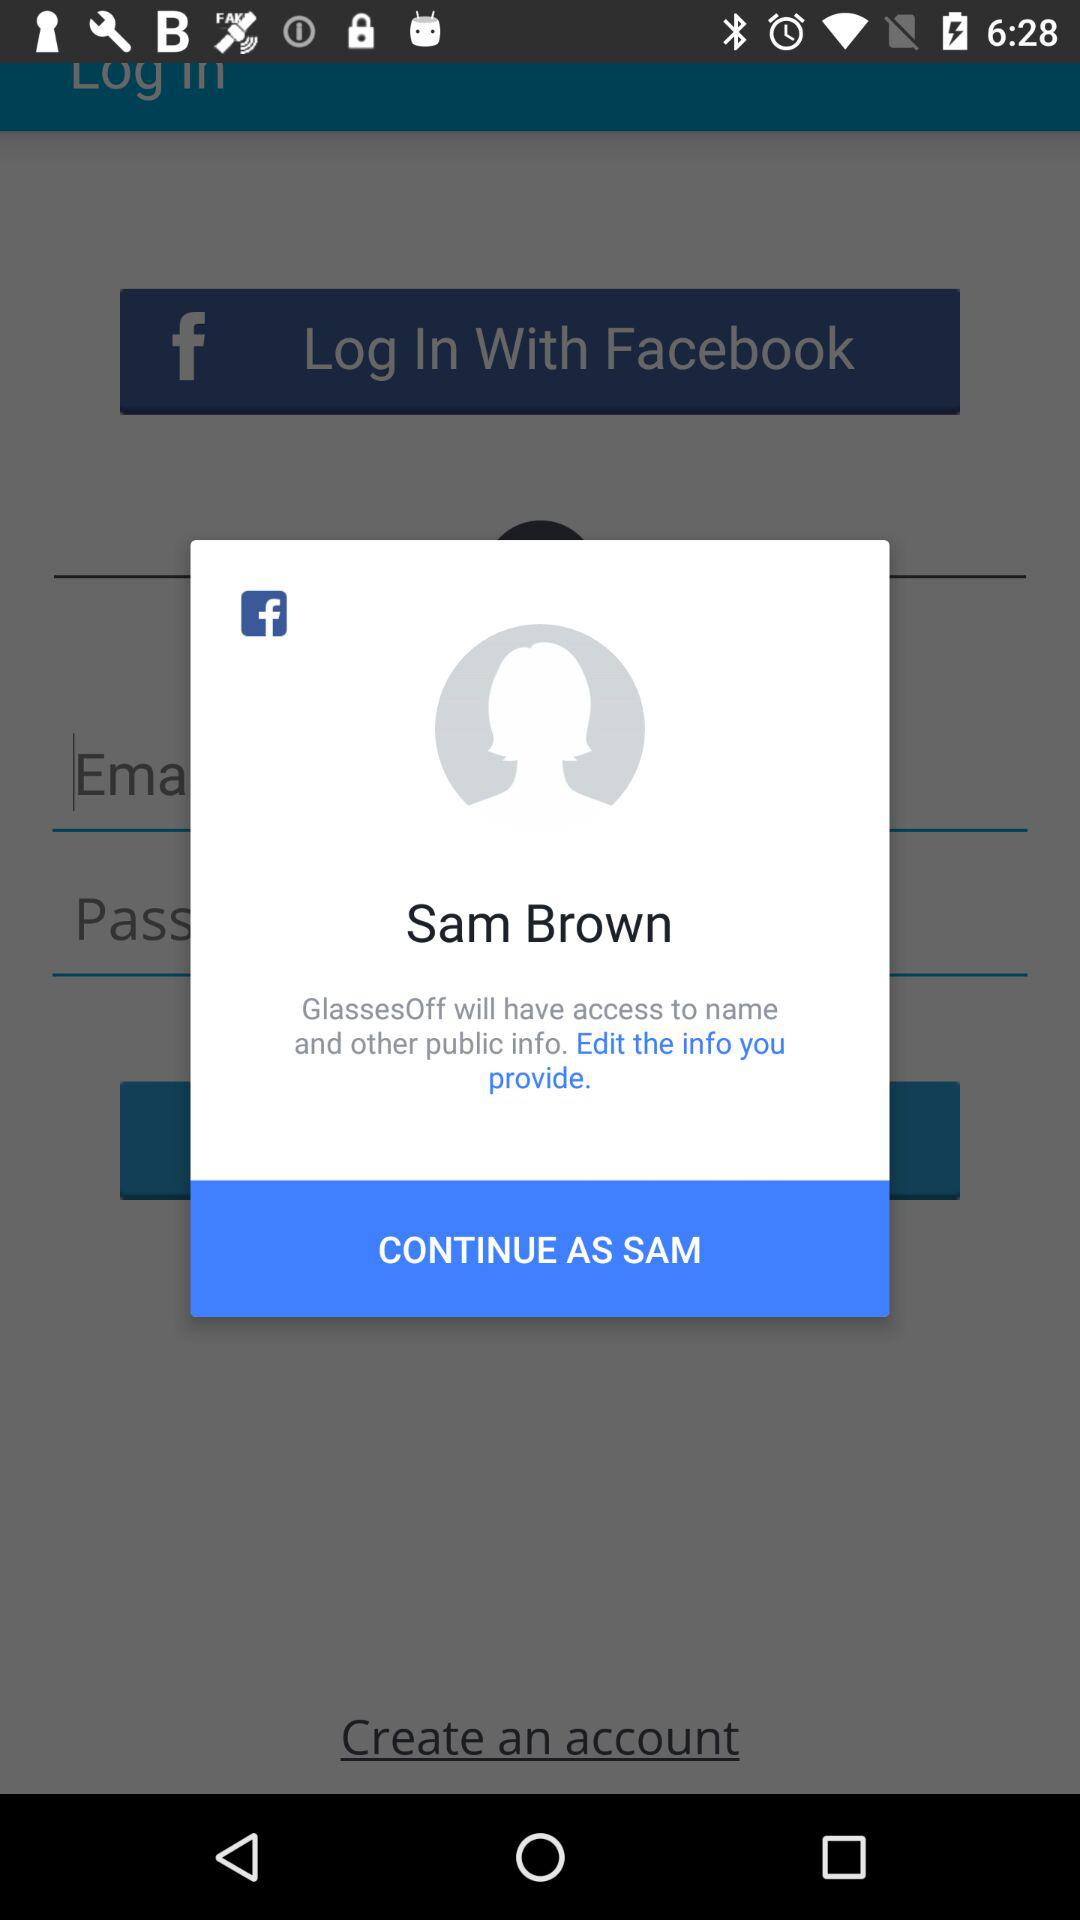Who will have the access to edit name, email and other public information?
When the provided information is insufficient, respond with <no answer>. <no answer> 